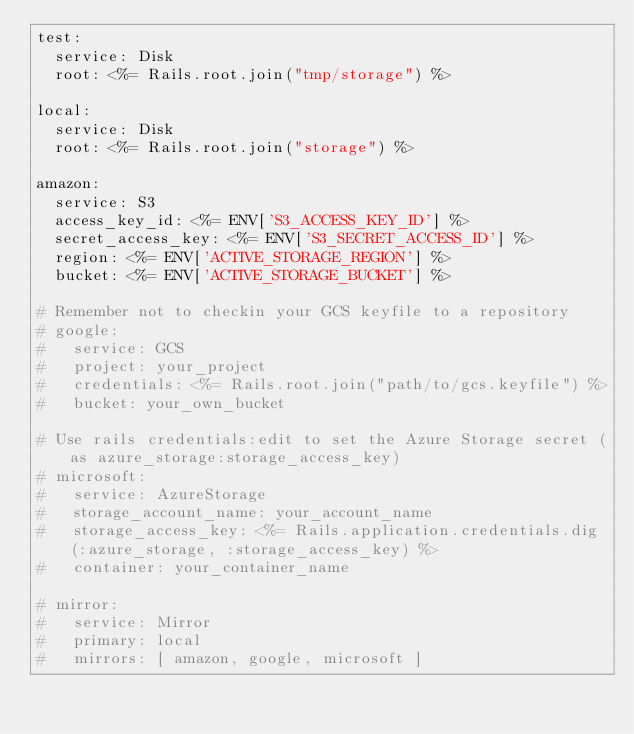Convert code to text. <code><loc_0><loc_0><loc_500><loc_500><_YAML_>test:
  service: Disk
  root: <%= Rails.root.join("tmp/storage") %>

local:
  service: Disk
  root: <%= Rails.root.join("storage") %>

amazon:
  service: S3
  access_key_id: <%= ENV['S3_ACCESS_KEY_ID'] %>
  secret_access_key: <%= ENV['S3_SECRET_ACCESS_ID'] %>
  region: <%= ENV['ACTIVE_STORAGE_REGION'] %>
  bucket: <%= ENV['ACTIVE_STORAGE_BUCKET'] %>

# Remember not to checkin your GCS keyfile to a repository
# google:
#   service: GCS
#   project: your_project
#   credentials: <%= Rails.root.join("path/to/gcs.keyfile") %>
#   bucket: your_own_bucket

# Use rails credentials:edit to set the Azure Storage secret (as azure_storage:storage_access_key)
# microsoft:
#   service: AzureStorage
#   storage_account_name: your_account_name
#   storage_access_key: <%= Rails.application.credentials.dig(:azure_storage, :storage_access_key) %>
#   container: your_container_name

# mirror:
#   service: Mirror
#   primary: local
#   mirrors: [ amazon, google, microsoft ]
</code> 